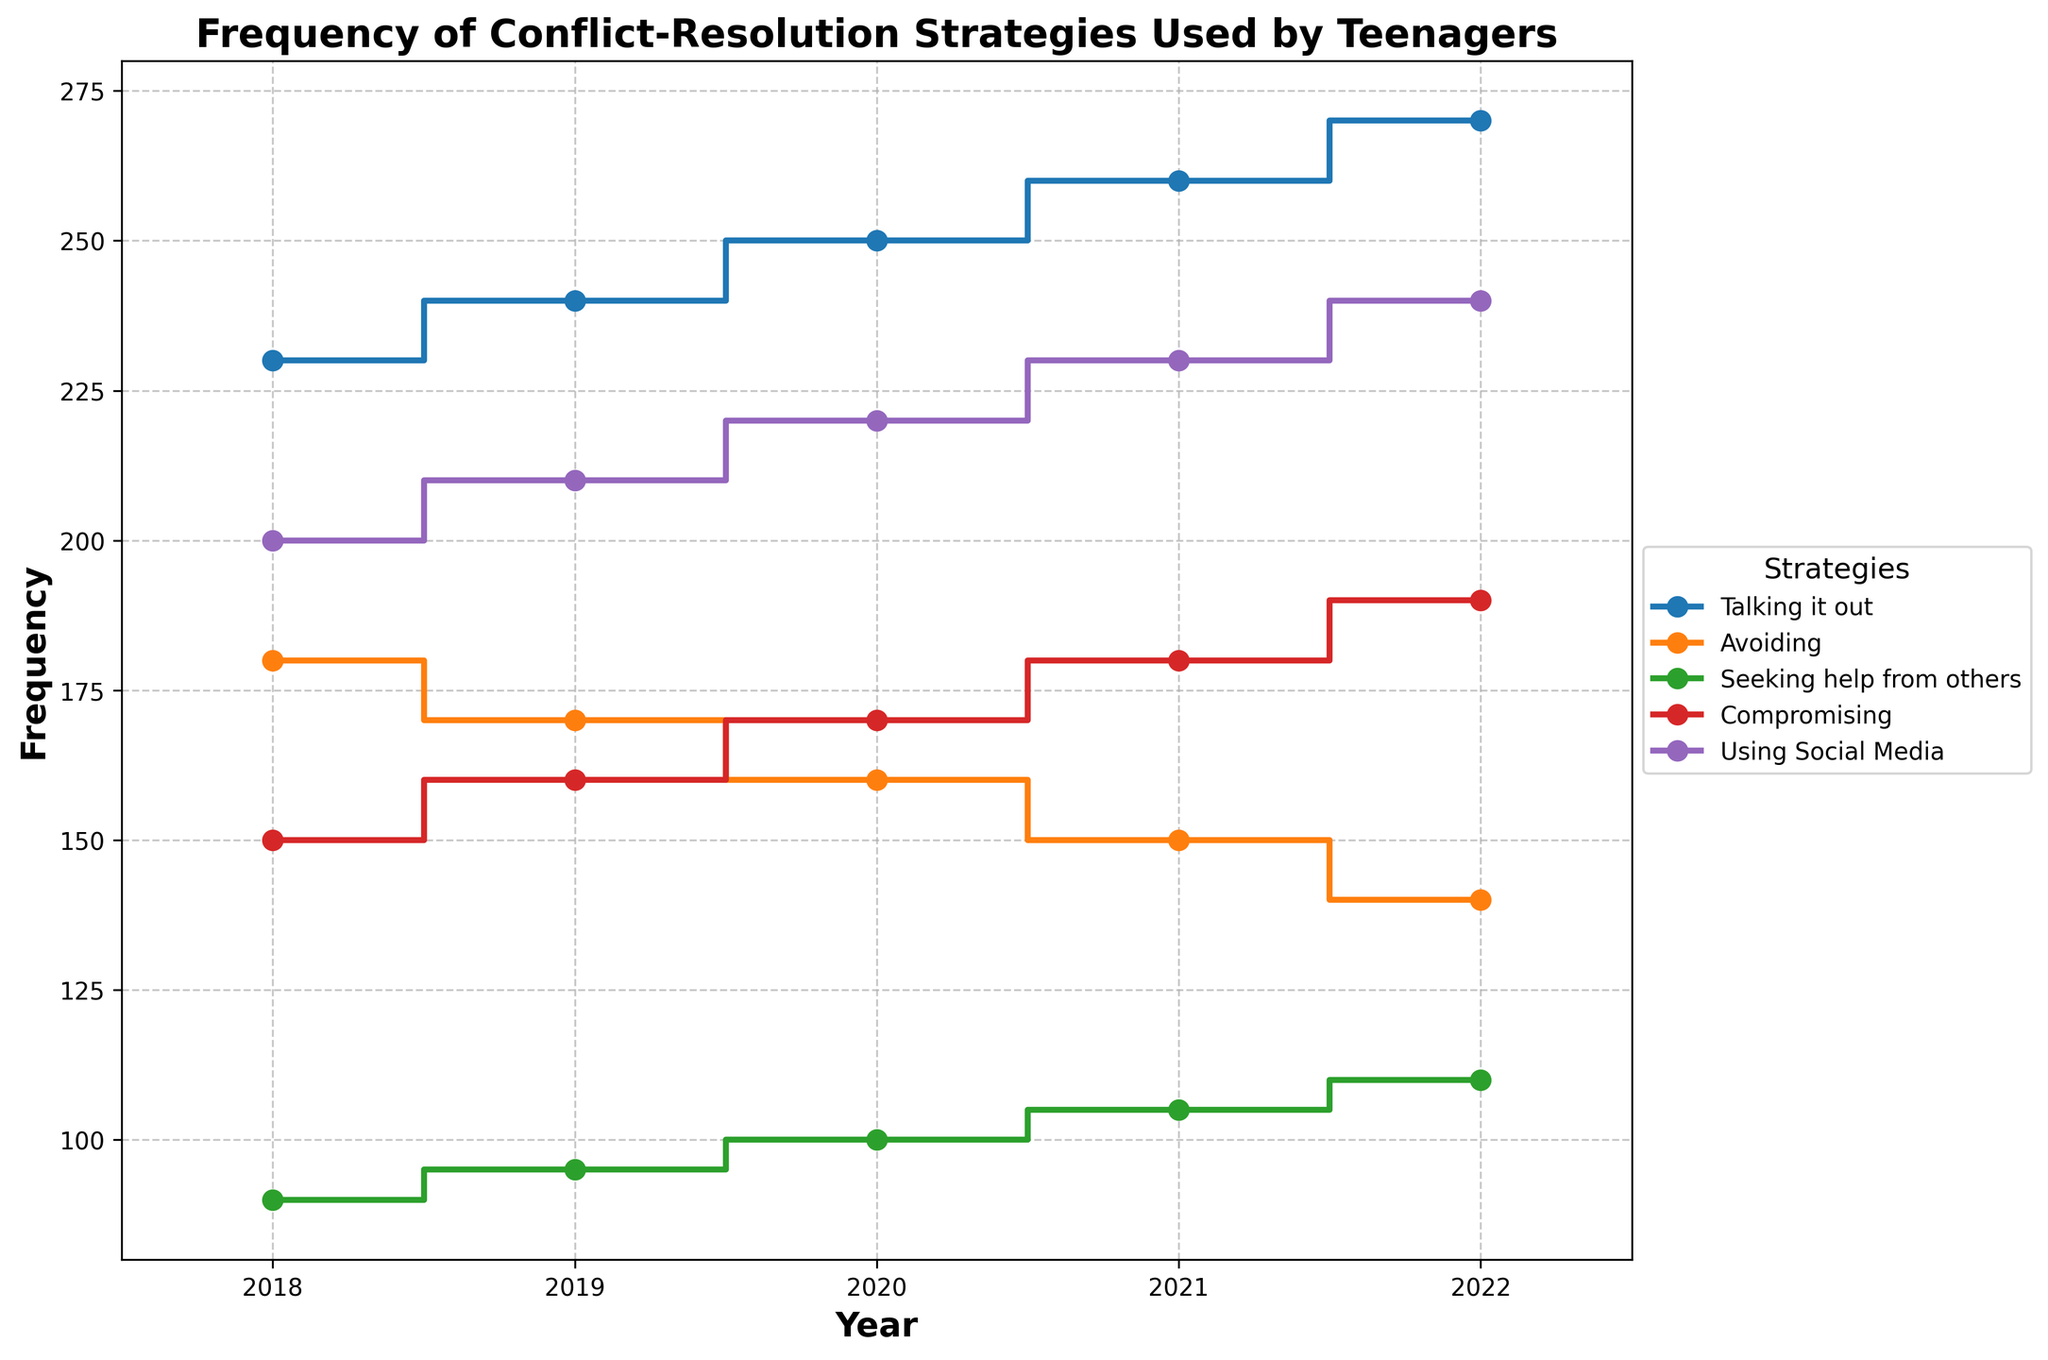How many different conflict-resolution strategies are displayed in the figure? The plot contains five different conflict-resolution strategies, as indicated by the legend. Each strategy is represented by a different line, making it easy to count them.
Answer: 5 What is the title of the figure? The title is clearly specified at the top of the plot, providing a descriptive overview of the data represented.
Answer: Frequency of Conflict-Resolution Strategies Used by Teenagers Which strategy had the highest frequency in 2022? By locating the point corresponding to 2022 on the x-axis and checking the highest position on the y-axis, it's evident that "Talking it out" had the highest frequency.
Answer: Talking it out How did the frequency of "Avoiding" change from 2018 to 2022? To determine the change, observe the frequency values for "Avoiding" at 2018 (180) and 2022 (140). The change is calculated by subtracting the 2022 value from the 2018 value.
Answer: Decreased by 40 Which strategy showed a consistent increase in frequency every year from 2018 to 2022? By examining each line's progression year by year, "Talking it out" is the only strategy that steadily increases each year.
Answer: Talking it out What is the difference in frequency between "Talking it out" and "Seeking help from others" in 2022? The frequency of "Talking it out" in 2022 is 270, and for "Seeking help from others" it is 110. Subtract the latter from the former to find the difference.
Answer: 160 Has the frequency of "Using Social Media" increased or decreased over the years shown? By tracking the line representing "Using Social Media" from 2018 to 2022, it's clear that the frequency increases each year, from 200 to 240.
Answer: Increased In which year did "Compromising" see the largest single-year increase in frequency? By checking the year-to-year changes for "Compromising", the largest single-year increase is between 2021 (180) and 2022 (190), a rise of 10.
Answer: 2022 Compare the trend of "Avoiding" with "Compromising" from 2018 to 2022. "Avoiding" consistently decreases every year, while "Compromising" shows continuous increases. This can be observed by their respective downward and upward trends.
Answer: Opposite trends What is the average frequency of "Talking it out" over the five years? To find the average, sum the frequencies of "Talking it out" from 2018 (230), 2019 (240), 2020 (250), 2021 (260), and 2022 (270) and divide by 5. So, (230+240+250+260+270)/5 = 250.
Answer: 250 